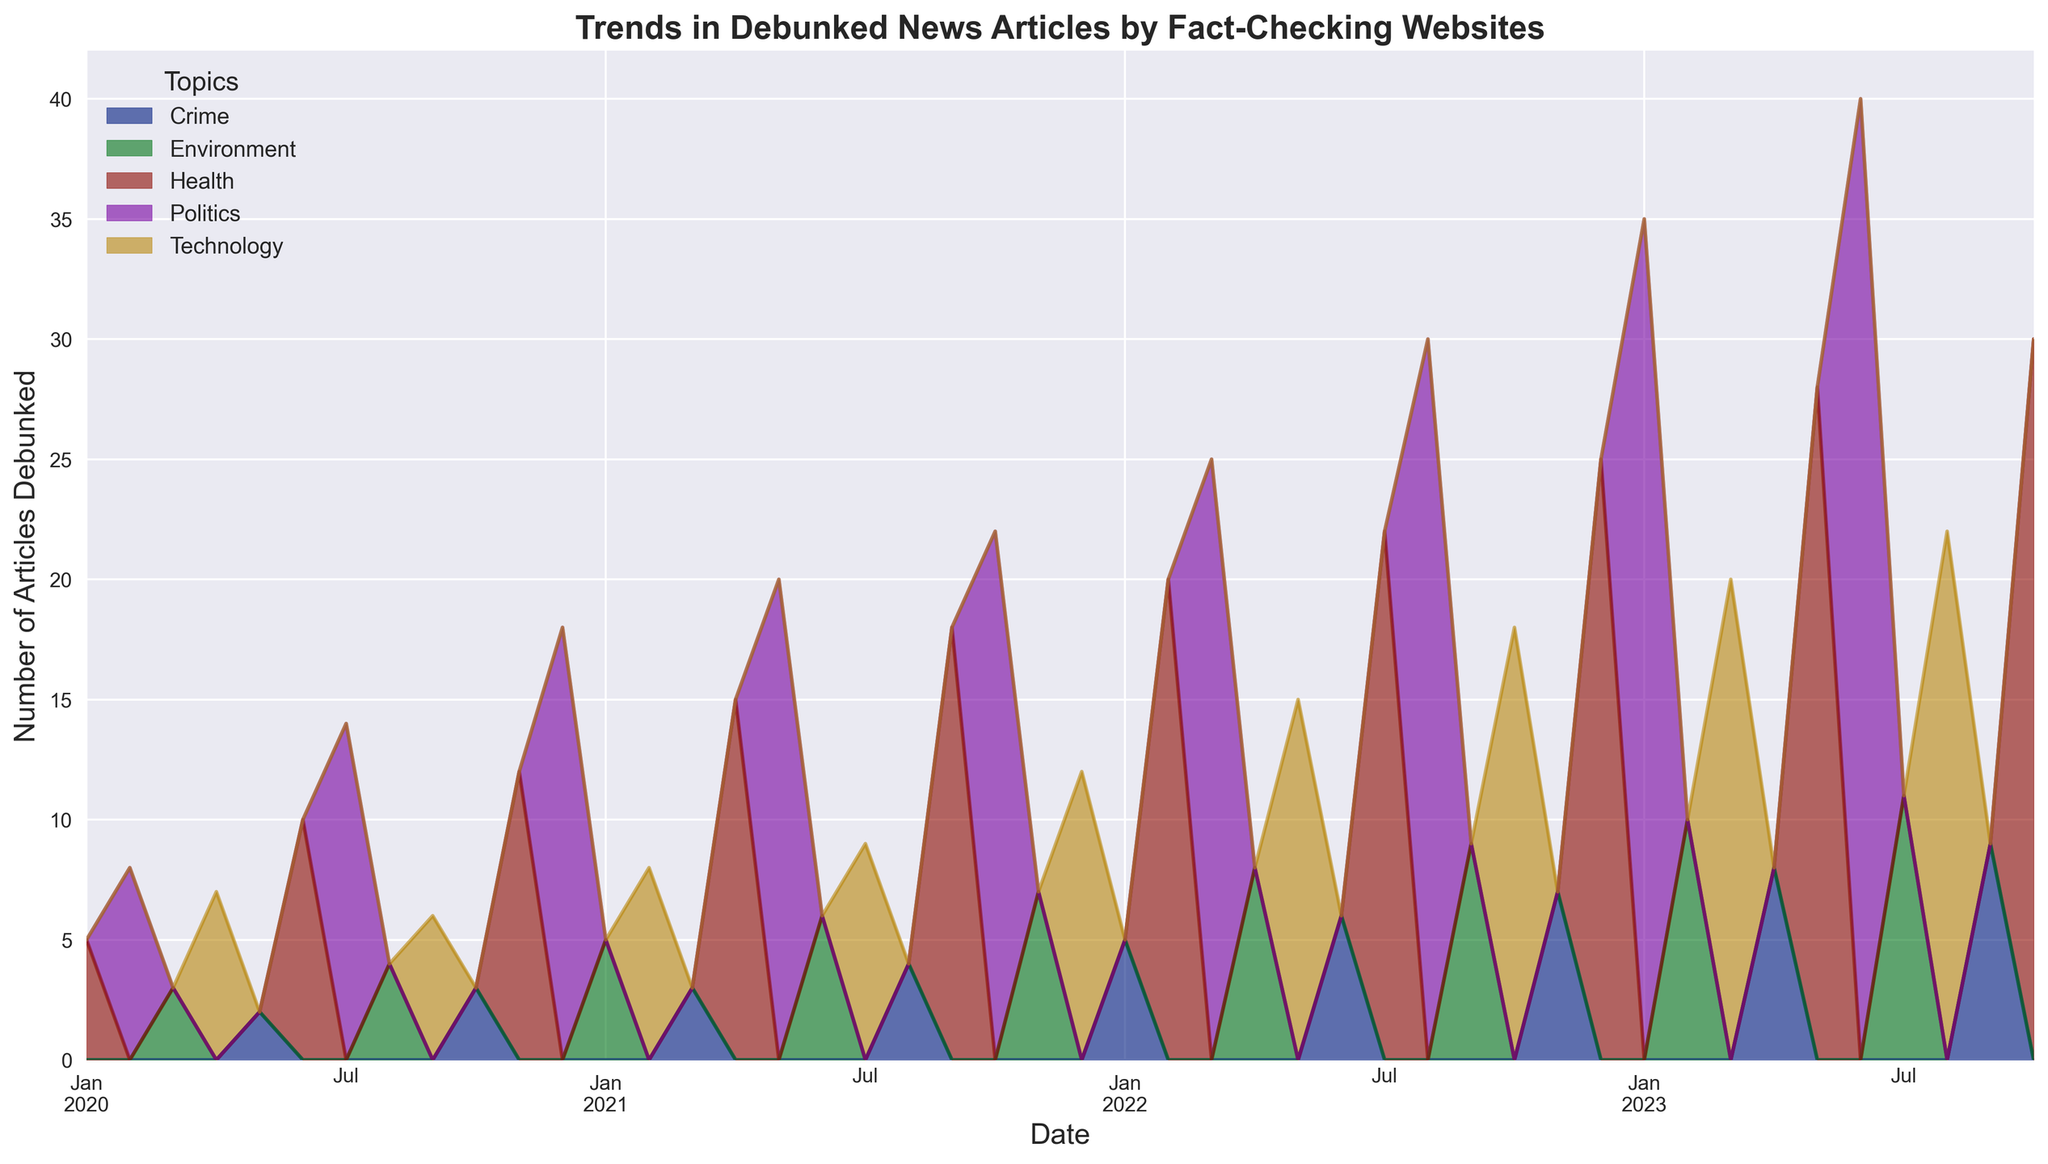What is the peak month for debunked "Health" articles? To find the peak month for "Health" articles, locate the time point where the "Health" area is at its highest. From the figure, it appears that October 2023 has the highest count.
Answer: October 2023 How does the count of debunked "Politics" articles in January 2023 compare to those in June 2023? To answer this, find the height of the "Politics" area for both January 2023 and June 2023. January 2023 has 35 articles, while June 2023 has 40 articles. Therefore, the count increases from January to June.
Answer: June 2023 is higher than January 2023 Which topic shows a declining trend from 2022 to 2023, if any? To answer this, observe the trend lines and areas for each topic from 2022 to 2023. The "Crime" topic appears to show a generally declining trend over this period.
Answer: Crime What's the difference between the maximum and minimum counts of debunked "Technology" articles? First, identify the maximum and minimum counts in the "Technology" area. The maximum is 22 (August 2023) and the minimum is 6 (September 2020). The difference is 22 - 6.
Answer: 16 How many months had exactly 5 debunked "Crime" articles? To find this, examine the "Crime" area and count the months where the value is exactly 5. These months are January 2022.
Answer: 1 Which topic had the highest count of debunked articles in July 2023? Look at the different colored areas corresponding to each topic in July 2023. The "Politics" area is the largest, so "Politics" had the highest count.
Answer: Politics What's the average count of debunked "Environment" articles from January 2021 to July 2021? Add up the counts of "Environment" articles from January 2021 to July 2021 and divide by the number of months (7). The counts are 5, 8, 6, 9. The average is (5 + 6 + 7 + 9 + 6 + 7 + 11) / 7 = 8.
Answer: 8 What is the general trend of debunked articles across all topics from January 2020 to October 2023? To determine the general trend, look at the overall height of the stacked area over this period. The total count appears to increase steadily over time.
Answer: Increasing In which month did "Health" articles first surpass 20 debunked articles? Look for the first point where the "Health" area crosses the 20-count mark. This occurs in February 2022.
Answer: February 2022 